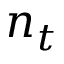Convert formula to latex. <formula><loc_0><loc_0><loc_500><loc_500>n _ { t }</formula> 